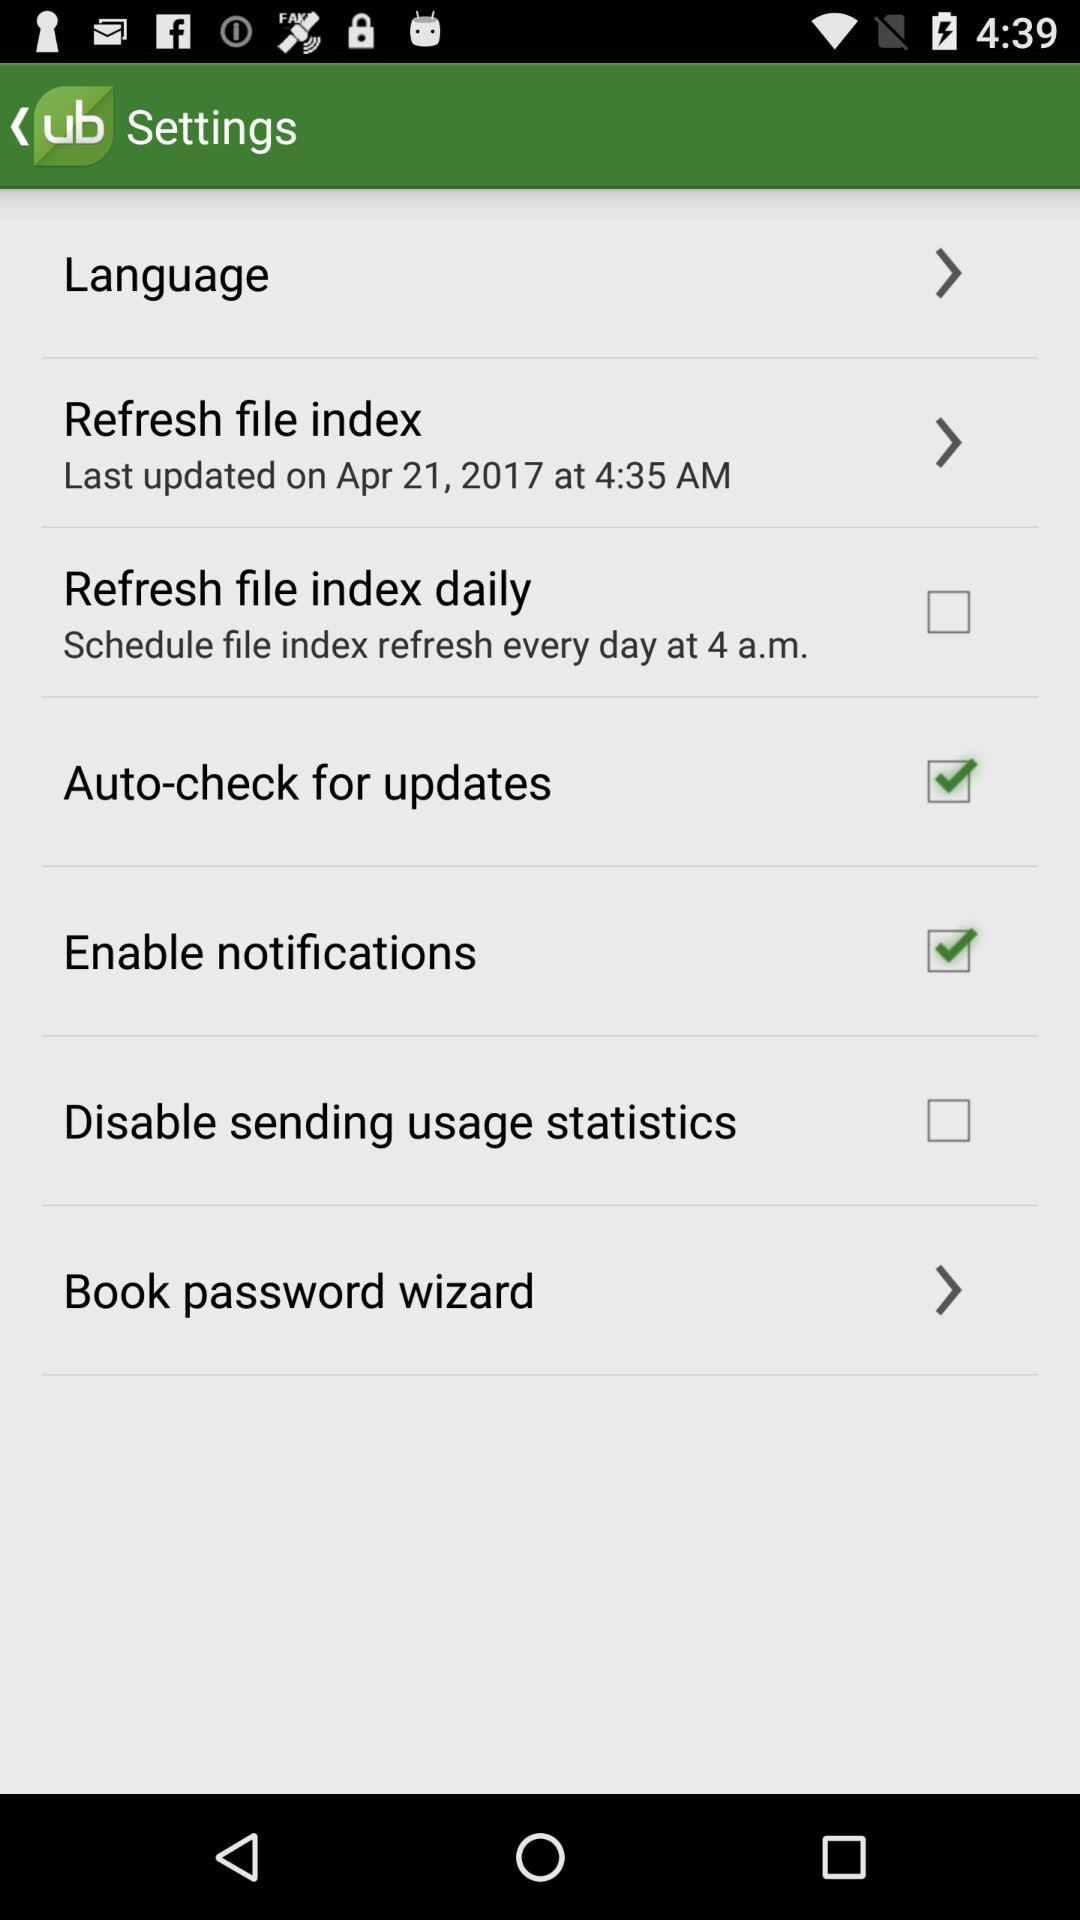What is the status of "Enable notifications"? The status is "on". 